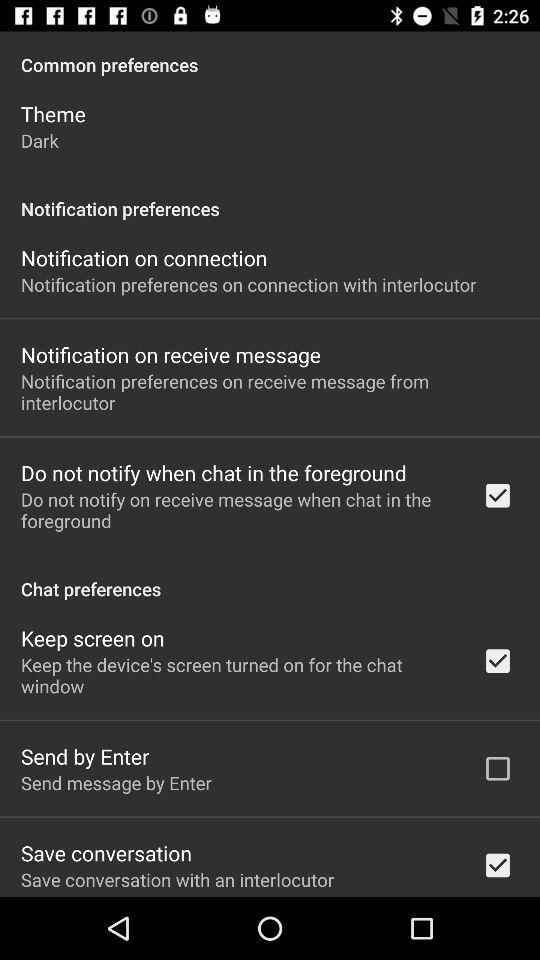What is the status of "Keep screen on"? The status is "on". 